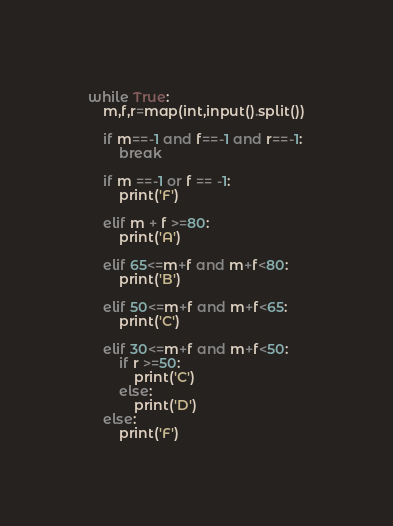Convert code to text. <code><loc_0><loc_0><loc_500><loc_500><_Python_>while True:
    m,f,r=map(int,input().split())

    if m==-1 and f==-1 and r==-1:
        break
    
    if m ==-1 or f == -1:
        print('F')
        
    elif m + f >=80:
        print('A')
        
    elif 65<=m+f and m+f<80:
        print('B')
    
    elif 50<=m+f and m+f<65:
        print('C')
        
    elif 30<=m+f and m+f<50:    
        if r >=50:
            print('C')
        else:
            print('D')
    else:
        print('F')
</code> 